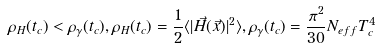Convert formula to latex. <formula><loc_0><loc_0><loc_500><loc_500>\rho _ { H } ( t _ { c } ) < \rho _ { \gamma } ( t _ { c } ) , \rho _ { H } ( t _ { c } ) = \frac { 1 } { 2 } \langle | \vec { H } ( \vec { x } ) | ^ { 2 } \rangle , \rho _ { \gamma } ( t _ { c } ) = \frac { \pi ^ { 2 } } { 3 0 } N _ { e f f } T ^ { 4 } _ { c }</formula> 